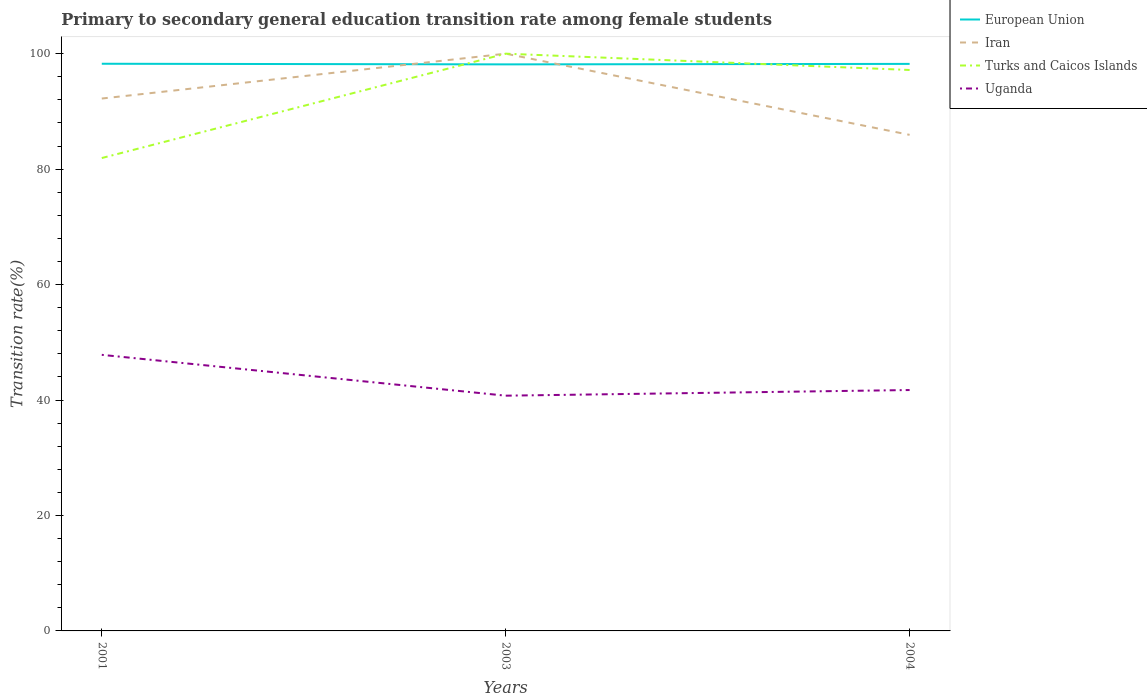How many different coloured lines are there?
Offer a very short reply. 4. Is the number of lines equal to the number of legend labels?
Ensure brevity in your answer.  Yes. Across all years, what is the maximum transition rate in Uganda?
Your answer should be compact. 40.75. What is the total transition rate in Turks and Caicos Islands in the graph?
Your answer should be very brief. -15.25. What is the difference between the highest and the second highest transition rate in Uganda?
Provide a succinct answer. 7.07. What is the difference between the highest and the lowest transition rate in Turks and Caicos Islands?
Your answer should be very brief. 2. How many lines are there?
Provide a short and direct response. 4. What is the difference between two consecutive major ticks on the Y-axis?
Your response must be concise. 20. Are the values on the major ticks of Y-axis written in scientific E-notation?
Your response must be concise. No. Does the graph contain grids?
Keep it short and to the point. No. Where does the legend appear in the graph?
Give a very brief answer. Top right. How are the legend labels stacked?
Your answer should be very brief. Vertical. What is the title of the graph?
Offer a very short reply. Primary to secondary general education transition rate among female students. Does "French Polynesia" appear as one of the legend labels in the graph?
Offer a terse response. No. What is the label or title of the Y-axis?
Offer a very short reply. Transition rate(%). What is the Transition rate(%) in European Union in 2001?
Offer a very short reply. 98.25. What is the Transition rate(%) in Iran in 2001?
Offer a very short reply. 92.23. What is the Transition rate(%) of Turks and Caicos Islands in 2001?
Keep it short and to the point. 81.92. What is the Transition rate(%) in Uganda in 2001?
Ensure brevity in your answer.  47.83. What is the Transition rate(%) of European Union in 2003?
Make the answer very short. 98.15. What is the Transition rate(%) in Iran in 2003?
Your answer should be very brief. 100. What is the Transition rate(%) in Turks and Caicos Islands in 2003?
Ensure brevity in your answer.  100. What is the Transition rate(%) of Uganda in 2003?
Make the answer very short. 40.75. What is the Transition rate(%) in European Union in 2004?
Make the answer very short. 98.23. What is the Transition rate(%) of Iran in 2004?
Make the answer very short. 85.94. What is the Transition rate(%) of Turks and Caicos Islands in 2004?
Your answer should be compact. 97.18. What is the Transition rate(%) in Uganda in 2004?
Ensure brevity in your answer.  41.73. Across all years, what is the maximum Transition rate(%) of European Union?
Provide a succinct answer. 98.25. Across all years, what is the maximum Transition rate(%) in Turks and Caicos Islands?
Your answer should be very brief. 100. Across all years, what is the maximum Transition rate(%) in Uganda?
Offer a very short reply. 47.83. Across all years, what is the minimum Transition rate(%) of European Union?
Your answer should be compact. 98.15. Across all years, what is the minimum Transition rate(%) of Iran?
Your answer should be compact. 85.94. Across all years, what is the minimum Transition rate(%) of Turks and Caicos Islands?
Offer a terse response. 81.92. Across all years, what is the minimum Transition rate(%) in Uganda?
Your answer should be very brief. 40.75. What is the total Transition rate(%) in European Union in the graph?
Keep it short and to the point. 294.63. What is the total Transition rate(%) in Iran in the graph?
Provide a succinct answer. 278.17. What is the total Transition rate(%) in Turks and Caicos Islands in the graph?
Make the answer very short. 279.1. What is the total Transition rate(%) in Uganda in the graph?
Your response must be concise. 130.31. What is the difference between the Transition rate(%) in European Union in 2001 and that in 2003?
Your answer should be very brief. 0.11. What is the difference between the Transition rate(%) of Iran in 2001 and that in 2003?
Provide a succinct answer. -7.77. What is the difference between the Transition rate(%) of Turks and Caicos Islands in 2001 and that in 2003?
Give a very brief answer. -18.08. What is the difference between the Transition rate(%) of Uganda in 2001 and that in 2003?
Your answer should be very brief. 7.07. What is the difference between the Transition rate(%) in European Union in 2001 and that in 2004?
Make the answer very short. 0.02. What is the difference between the Transition rate(%) in Iran in 2001 and that in 2004?
Your response must be concise. 6.29. What is the difference between the Transition rate(%) of Turks and Caicos Islands in 2001 and that in 2004?
Your answer should be compact. -15.25. What is the difference between the Transition rate(%) in Uganda in 2001 and that in 2004?
Ensure brevity in your answer.  6.1. What is the difference between the Transition rate(%) in European Union in 2003 and that in 2004?
Offer a very short reply. -0.09. What is the difference between the Transition rate(%) of Iran in 2003 and that in 2004?
Keep it short and to the point. 14.06. What is the difference between the Transition rate(%) in Turks and Caicos Islands in 2003 and that in 2004?
Offer a very short reply. 2.82. What is the difference between the Transition rate(%) in Uganda in 2003 and that in 2004?
Provide a short and direct response. -0.98. What is the difference between the Transition rate(%) of European Union in 2001 and the Transition rate(%) of Iran in 2003?
Ensure brevity in your answer.  -1.75. What is the difference between the Transition rate(%) in European Union in 2001 and the Transition rate(%) in Turks and Caicos Islands in 2003?
Your answer should be compact. -1.75. What is the difference between the Transition rate(%) in European Union in 2001 and the Transition rate(%) in Uganda in 2003?
Your answer should be compact. 57.5. What is the difference between the Transition rate(%) in Iran in 2001 and the Transition rate(%) in Turks and Caicos Islands in 2003?
Your response must be concise. -7.77. What is the difference between the Transition rate(%) in Iran in 2001 and the Transition rate(%) in Uganda in 2003?
Your answer should be compact. 51.48. What is the difference between the Transition rate(%) of Turks and Caicos Islands in 2001 and the Transition rate(%) of Uganda in 2003?
Make the answer very short. 41.17. What is the difference between the Transition rate(%) in European Union in 2001 and the Transition rate(%) in Iran in 2004?
Offer a terse response. 12.32. What is the difference between the Transition rate(%) of European Union in 2001 and the Transition rate(%) of Turks and Caicos Islands in 2004?
Offer a very short reply. 1.08. What is the difference between the Transition rate(%) of European Union in 2001 and the Transition rate(%) of Uganda in 2004?
Make the answer very short. 56.52. What is the difference between the Transition rate(%) of Iran in 2001 and the Transition rate(%) of Turks and Caicos Islands in 2004?
Your answer should be compact. -4.95. What is the difference between the Transition rate(%) in Iran in 2001 and the Transition rate(%) in Uganda in 2004?
Your answer should be very brief. 50.5. What is the difference between the Transition rate(%) of Turks and Caicos Islands in 2001 and the Transition rate(%) of Uganda in 2004?
Offer a very short reply. 40.19. What is the difference between the Transition rate(%) of European Union in 2003 and the Transition rate(%) of Iran in 2004?
Keep it short and to the point. 12.21. What is the difference between the Transition rate(%) in European Union in 2003 and the Transition rate(%) in Turks and Caicos Islands in 2004?
Offer a very short reply. 0.97. What is the difference between the Transition rate(%) of European Union in 2003 and the Transition rate(%) of Uganda in 2004?
Ensure brevity in your answer.  56.41. What is the difference between the Transition rate(%) in Iran in 2003 and the Transition rate(%) in Turks and Caicos Islands in 2004?
Your answer should be compact. 2.82. What is the difference between the Transition rate(%) of Iran in 2003 and the Transition rate(%) of Uganda in 2004?
Give a very brief answer. 58.27. What is the difference between the Transition rate(%) in Turks and Caicos Islands in 2003 and the Transition rate(%) in Uganda in 2004?
Your answer should be compact. 58.27. What is the average Transition rate(%) in European Union per year?
Make the answer very short. 98.21. What is the average Transition rate(%) in Iran per year?
Provide a short and direct response. 92.72. What is the average Transition rate(%) of Turks and Caicos Islands per year?
Provide a succinct answer. 93.03. What is the average Transition rate(%) in Uganda per year?
Provide a short and direct response. 43.44. In the year 2001, what is the difference between the Transition rate(%) in European Union and Transition rate(%) in Iran?
Ensure brevity in your answer.  6.02. In the year 2001, what is the difference between the Transition rate(%) of European Union and Transition rate(%) of Turks and Caicos Islands?
Your answer should be compact. 16.33. In the year 2001, what is the difference between the Transition rate(%) in European Union and Transition rate(%) in Uganda?
Make the answer very short. 50.43. In the year 2001, what is the difference between the Transition rate(%) in Iran and Transition rate(%) in Turks and Caicos Islands?
Ensure brevity in your answer.  10.31. In the year 2001, what is the difference between the Transition rate(%) of Iran and Transition rate(%) of Uganda?
Provide a short and direct response. 44.4. In the year 2001, what is the difference between the Transition rate(%) in Turks and Caicos Islands and Transition rate(%) in Uganda?
Offer a very short reply. 34.09. In the year 2003, what is the difference between the Transition rate(%) in European Union and Transition rate(%) in Iran?
Offer a terse response. -1.85. In the year 2003, what is the difference between the Transition rate(%) in European Union and Transition rate(%) in Turks and Caicos Islands?
Offer a terse response. -1.85. In the year 2003, what is the difference between the Transition rate(%) of European Union and Transition rate(%) of Uganda?
Your answer should be compact. 57.39. In the year 2003, what is the difference between the Transition rate(%) in Iran and Transition rate(%) in Turks and Caicos Islands?
Make the answer very short. 0. In the year 2003, what is the difference between the Transition rate(%) of Iran and Transition rate(%) of Uganda?
Give a very brief answer. 59.25. In the year 2003, what is the difference between the Transition rate(%) in Turks and Caicos Islands and Transition rate(%) in Uganda?
Offer a terse response. 59.25. In the year 2004, what is the difference between the Transition rate(%) of European Union and Transition rate(%) of Iran?
Ensure brevity in your answer.  12.29. In the year 2004, what is the difference between the Transition rate(%) of European Union and Transition rate(%) of Turks and Caicos Islands?
Provide a short and direct response. 1.06. In the year 2004, what is the difference between the Transition rate(%) of European Union and Transition rate(%) of Uganda?
Your answer should be compact. 56.5. In the year 2004, what is the difference between the Transition rate(%) of Iran and Transition rate(%) of Turks and Caicos Islands?
Offer a terse response. -11.24. In the year 2004, what is the difference between the Transition rate(%) in Iran and Transition rate(%) in Uganda?
Your answer should be compact. 44.21. In the year 2004, what is the difference between the Transition rate(%) in Turks and Caicos Islands and Transition rate(%) in Uganda?
Ensure brevity in your answer.  55.44. What is the ratio of the Transition rate(%) of Iran in 2001 to that in 2003?
Give a very brief answer. 0.92. What is the ratio of the Transition rate(%) in Turks and Caicos Islands in 2001 to that in 2003?
Your response must be concise. 0.82. What is the ratio of the Transition rate(%) of Uganda in 2001 to that in 2003?
Your answer should be very brief. 1.17. What is the ratio of the Transition rate(%) of Iran in 2001 to that in 2004?
Keep it short and to the point. 1.07. What is the ratio of the Transition rate(%) of Turks and Caicos Islands in 2001 to that in 2004?
Give a very brief answer. 0.84. What is the ratio of the Transition rate(%) of Uganda in 2001 to that in 2004?
Ensure brevity in your answer.  1.15. What is the ratio of the Transition rate(%) in Iran in 2003 to that in 2004?
Offer a terse response. 1.16. What is the ratio of the Transition rate(%) in Turks and Caicos Islands in 2003 to that in 2004?
Provide a short and direct response. 1.03. What is the ratio of the Transition rate(%) of Uganda in 2003 to that in 2004?
Make the answer very short. 0.98. What is the difference between the highest and the second highest Transition rate(%) of European Union?
Ensure brevity in your answer.  0.02. What is the difference between the highest and the second highest Transition rate(%) in Iran?
Provide a short and direct response. 7.77. What is the difference between the highest and the second highest Transition rate(%) of Turks and Caicos Islands?
Give a very brief answer. 2.82. What is the difference between the highest and the second highest Transition rate(%) in Uganda?
Give a very brief answer. 6.1. What is the difference between the highest and the lowest Transition rate(%) of European Union?
Ensure brevity in your answer.  0.11. What is the difference between the highest and the lowest Transition rate(%) in Iran?
Your answer should be compact. 14.06. What is the difference between the highest and the lowest Transition rate(%) of Turks and Caicos Islands?
Ensure brevity in your answer.  18.08. What is the difference between the highest and the lowest Transition rate(%) of Uganda?
Your response must be concise. 7.07. 